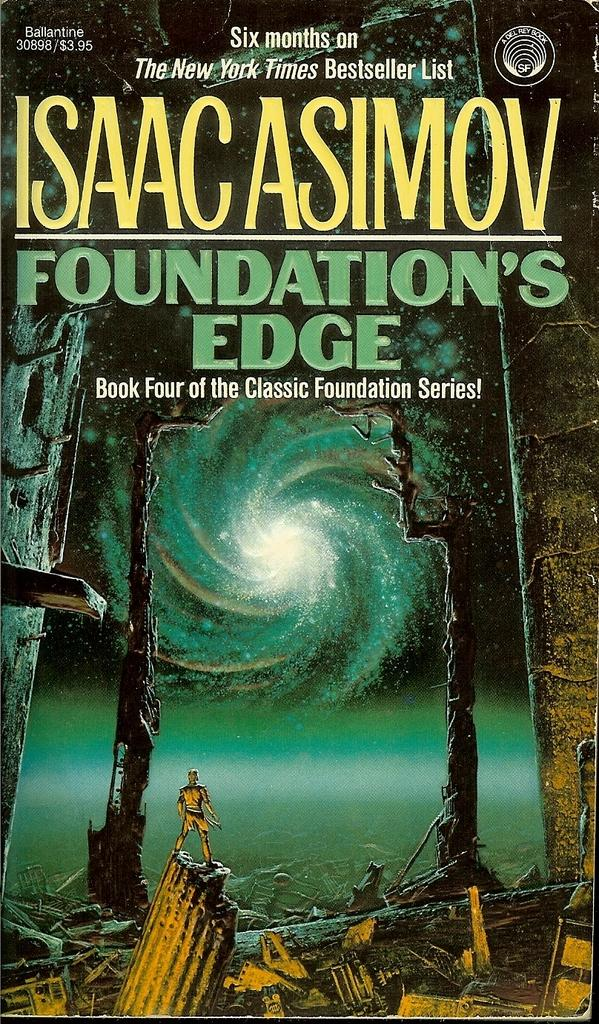<image>
Give a short and clear explanation of the subsequent image. Science fiction book cover that appears to be under 4 dollars 